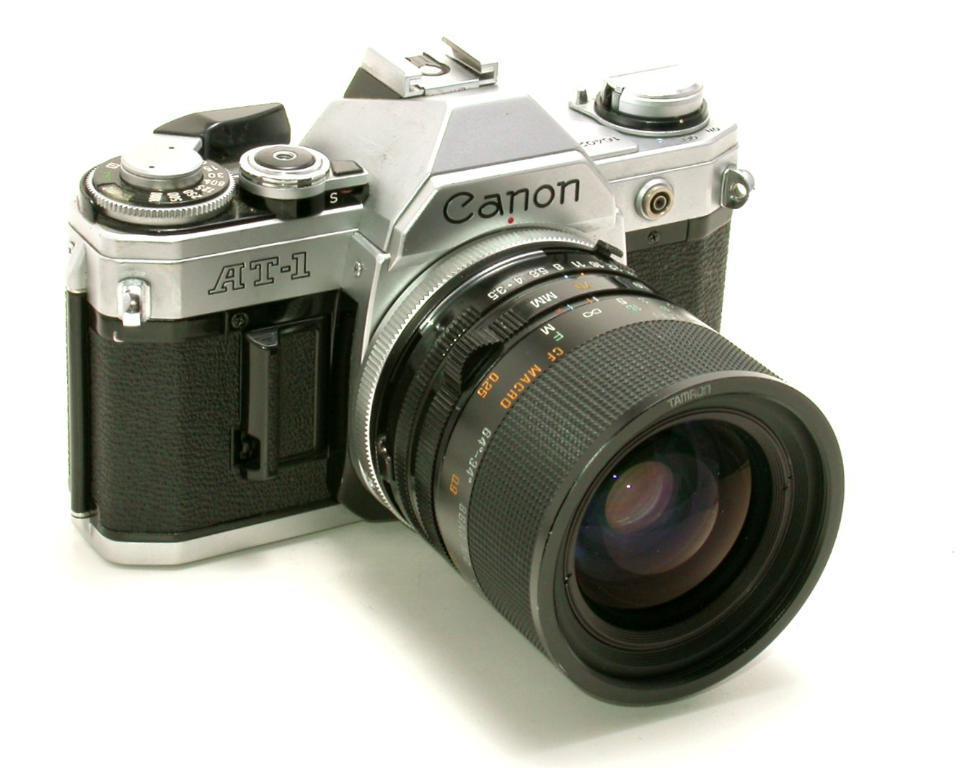How would you summarize this image in a sentence or two? In this image, we can see a camera which is in black and gray color. In the background, we can see white color. 